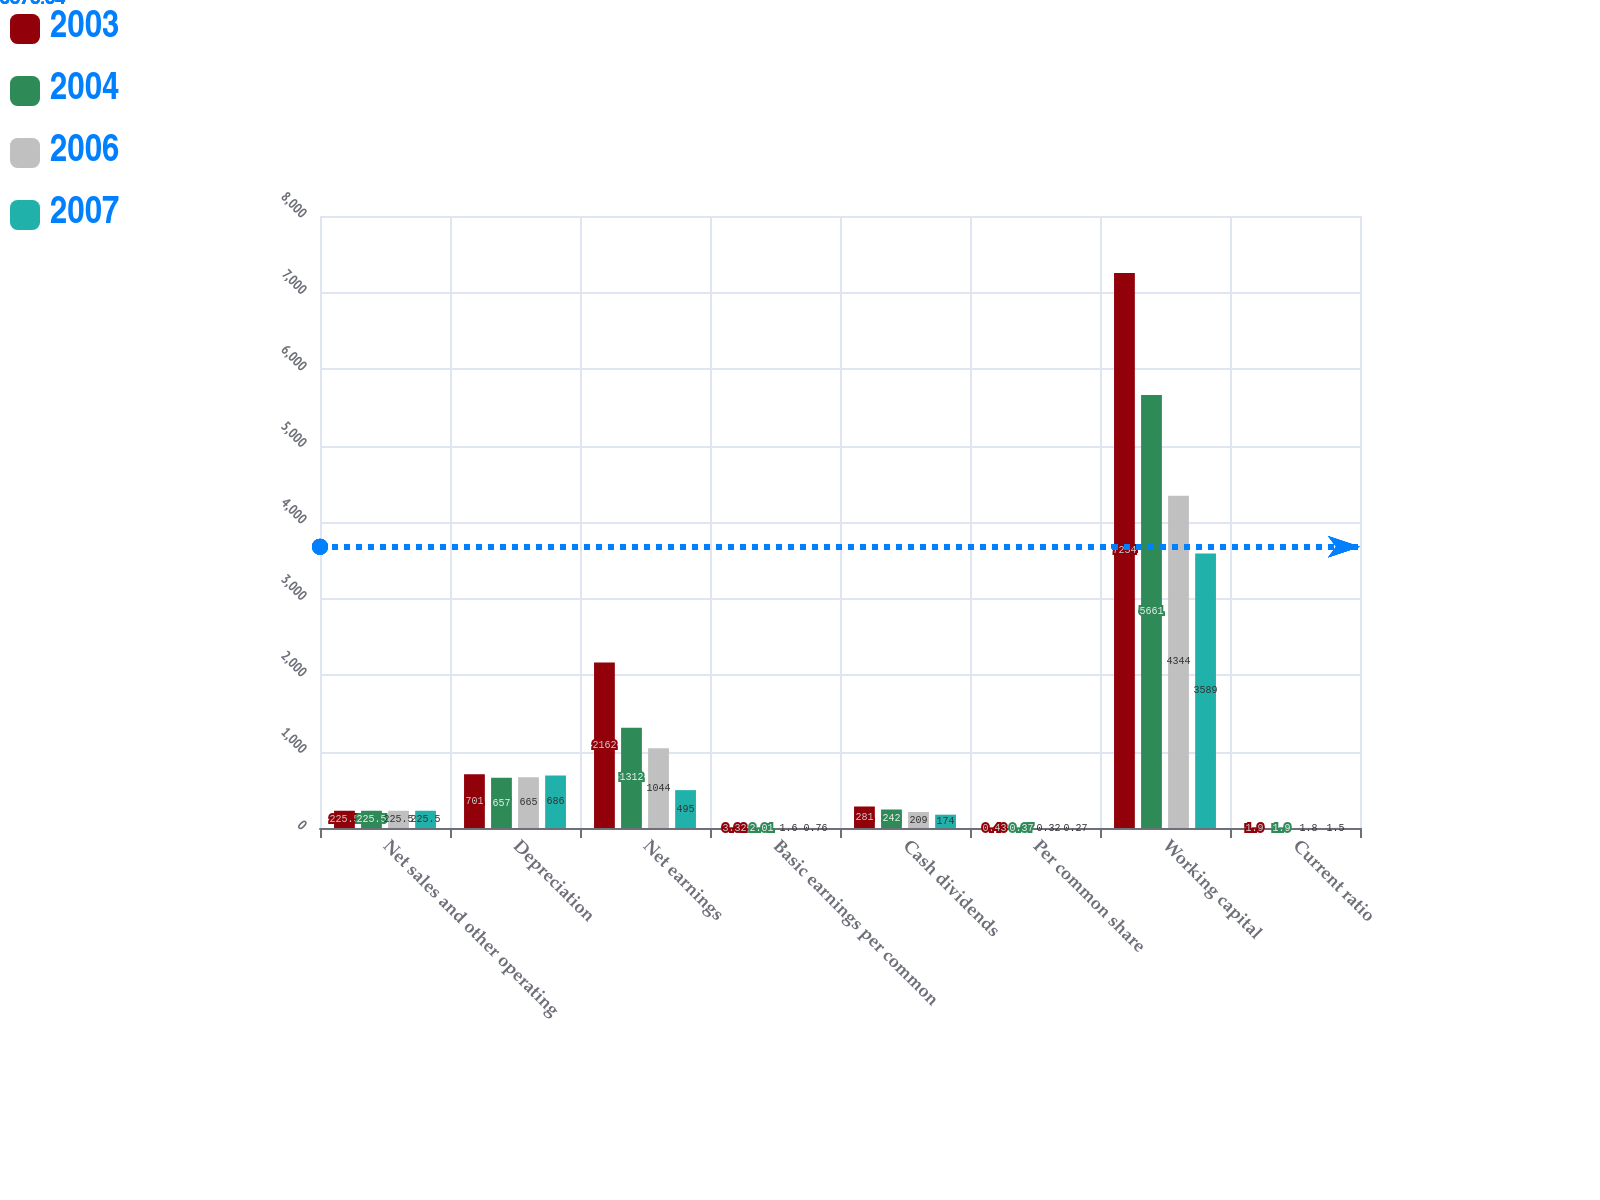<chart> <loc_0><loc_0><loc_500><loc_500><stacked_bar_chart><ecel><fcel>Net sales and other operating<fcel>Depreciation<fcel>Net earnings<fcel>Basic earnings per common<fcel>Cash dividends<fcel>Per common share<fcel>Working capital<fcel>Current ratio<nl><fcel>2003<fcel>225.5<fcel>701<fcel>2162<fcel>3.32<fcel>281<fcel>0.43<fcel>7254<fcel>1.9<nl><fcel>2004<fcel>225.5<fcel>657<fcel>1312<fcel>2.01<fcel>242<fcel>0.37<fcel>5661<fcel>1.9<nl><fcel>2006<fcel>225.5<fcel>665<fcel>1044<fcel>1.6<fcel>209<fcel>0.32<fcel>4344<fcel>1.8<nl><fcel>2007<fcel>225.5<fcel>686<fcel>495<fcel>0.76<fcel>174<fcel>0.27<fcel>3589<fcel>1.5<nl></chart> 